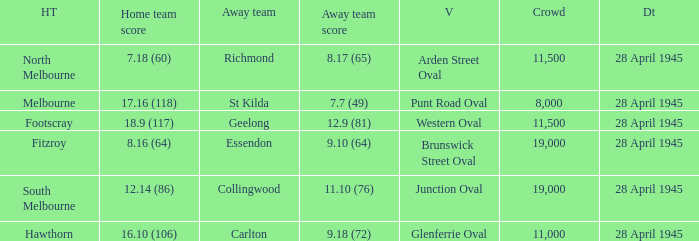Parse the full table. {'header': ['HT', 'Home team score', 'Away team', 'Away team score', 'V', 'Crowd', 'Dt'], 'rows': [['North Melbourne', '7.18 (60)', 'Richmond', '8.17 (65)', 'Arden Street Oval', '11,500', '28 April 1945'], ['Melbourne', '17.16 (118)', 'St Kilda', '7.7 (49)', 'Punt Road Oval', '8,000', '28 April 1945'], ['Footscray', '18.9 (117)', 'Geelong', '12.9 (81)', 'Western Oval', '11,500', '28 April 1945'], ['Fitzroy', '8.16 (64)', 'Essendon', '9.10 (64)', 'Brunswick Street Oval', '19,000', '28 April 1945'], ['South Melbourne', '12.14 (86)', 'Collingwood', '11.10 (76)', 'Junction Oval', '19,000', '28 April 1945'], ['Hawthorn', '16.10 (106)', 'Carlton', '9.18 (72)', 'Glenferrie Oval', '11,000', '28 April 1945']]} Which home team has an Away team of essendon? 8.16 (64). 